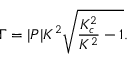<formula> <loc_0><loc_0><loc_500><loc_500>\Gamma = | P | K ^ { 2 } \sqrt { \frac { K _ { c } ^ { 2 } } { K ^ { 2 } } - 1 } .</formula> 